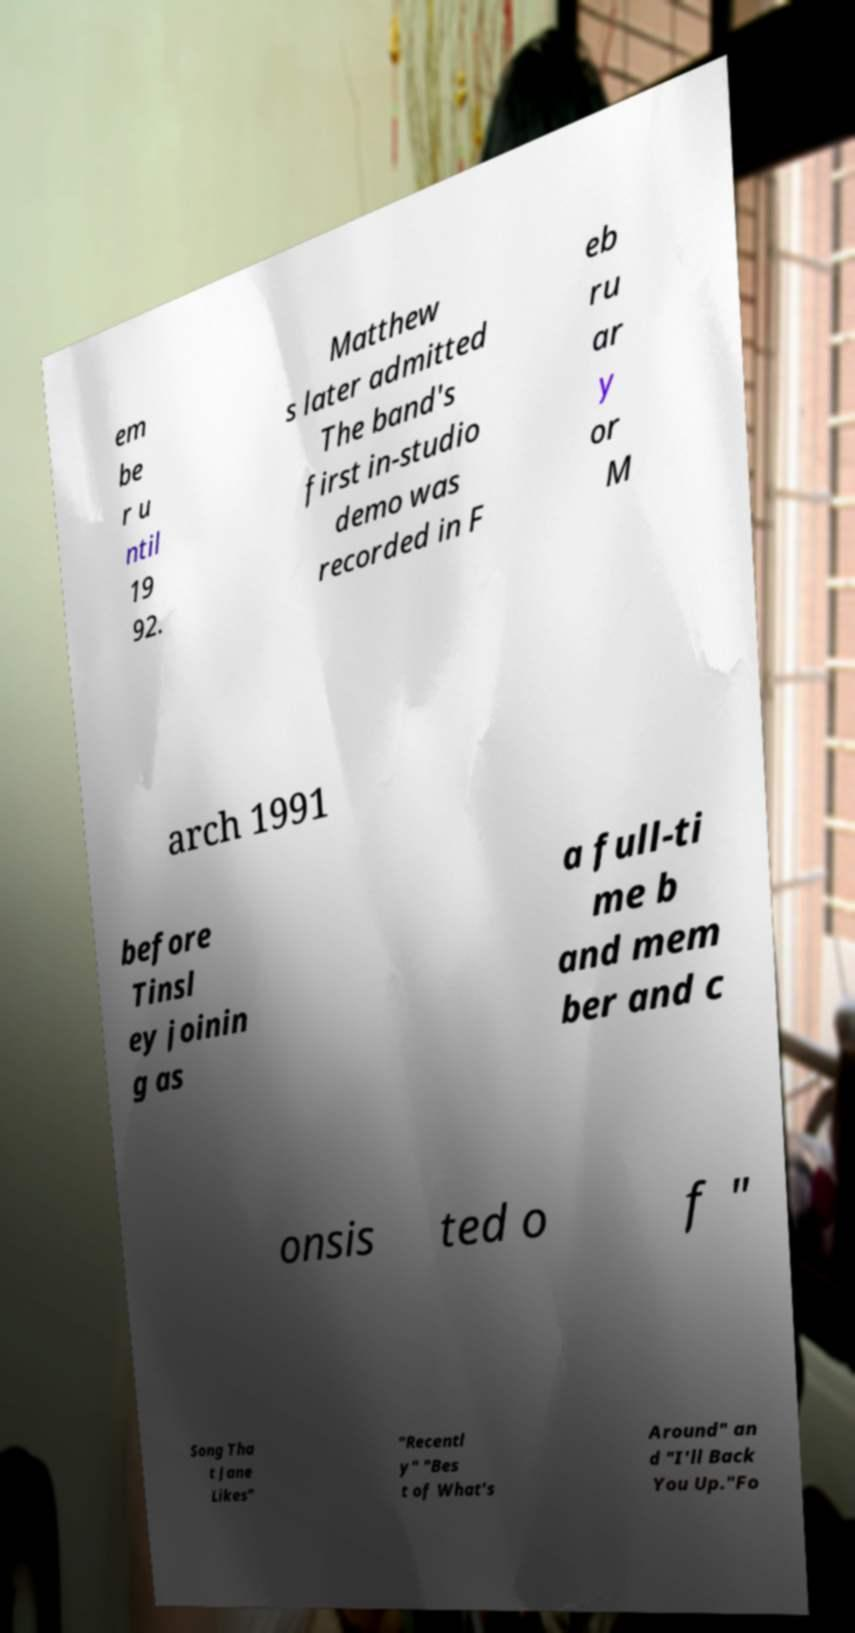Please read and relay the text visible in this image. What does it say? em be r u ntil 19 92. Matthew s later admitted The band's first in-studio demo was recorded in F eb ru ar y or M arch 1991 before Tinsl ey joinin g as a full-ti me b and mem ber and c onsis ted o f " Song Tha t Jane Likes" "Recentl y" "Bes t of What's Around" an d "I'll Back You Up."Fo 